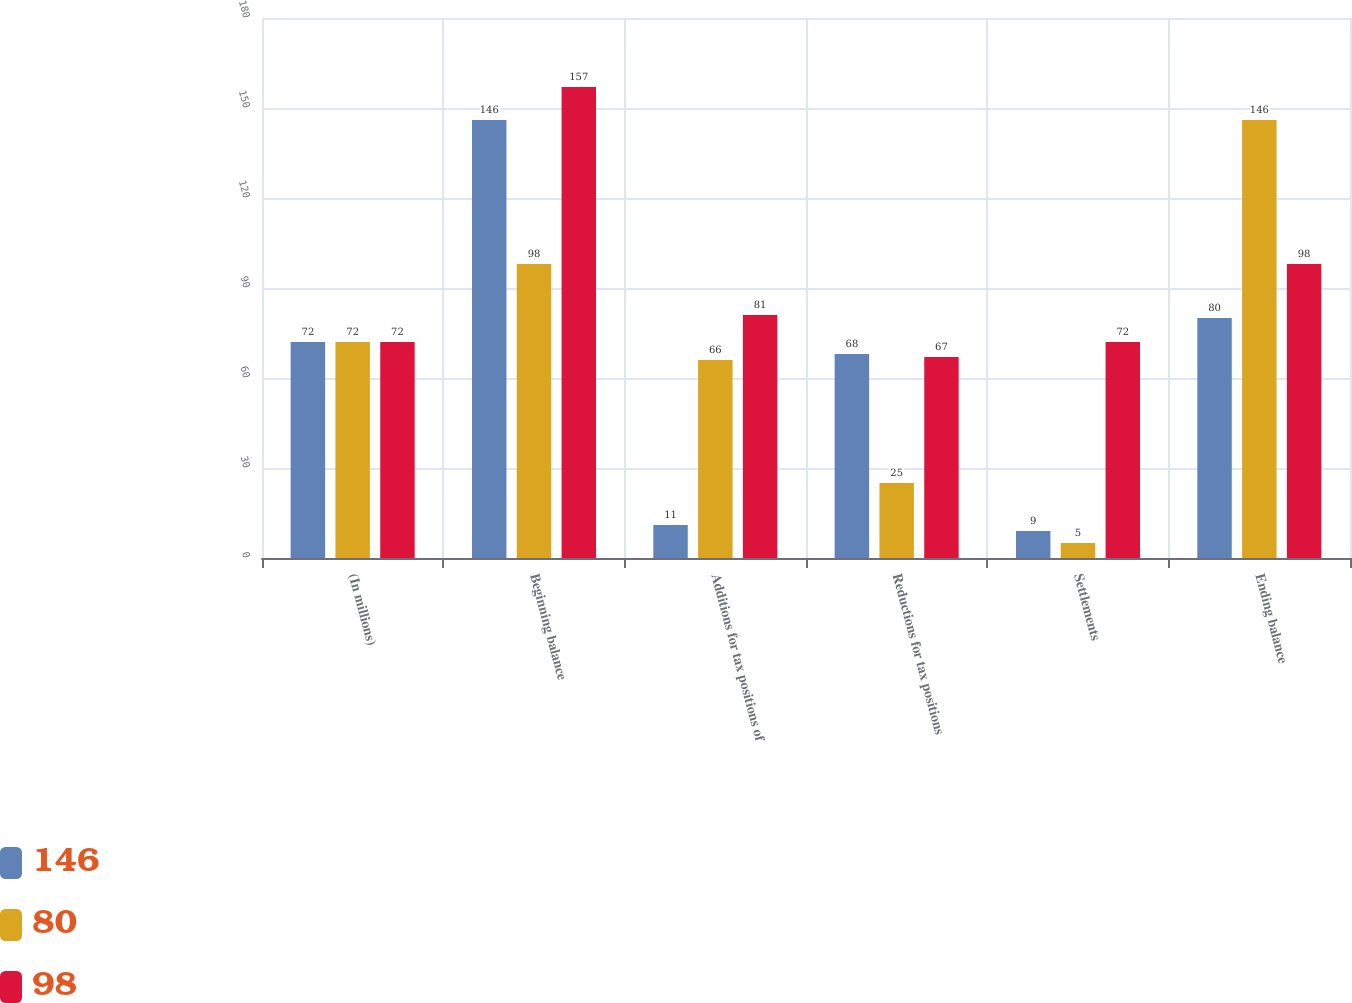Convert chart to OTSL. <chart><loc_0><loc_0><loc_500><loc_500><stacked_bar_chart><ecel><fcel>(In millions)<fcel>Beginning balance<fcel>Additions for tax positions of<fcel>Reductions for tax positions<fcel>Settlements<fcel>Ending balance<nl><fcel>146<fcel>72<fcel>146<fcel>11<fcel>68<fcel>9<fcel>80<nl><fcel>80<fcel>72<fcel>98<fcel>66<fcel>25<fcel>5<fcel>146<nl><fcel>98<fcel>72<fcel>157<fcel>81<fcel>67<fcel>72<fcel>98<nl></chart> 